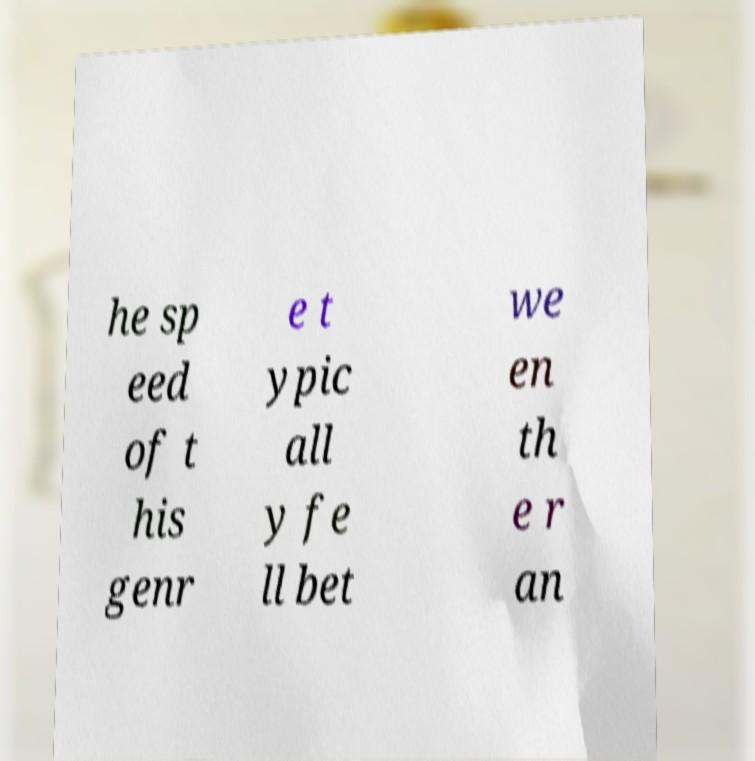Please identify and transcribe the text found in this image. he sp eed of t his genr e t ypic all y fe ll bet we en th e r an 